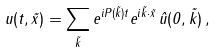<formula> <loc_0><loc_0><loc_500><loc_500>u ( t , \vec { x } ) = \sum _ { \vec { k } } e ^ { i P ( \vec { k } ) t } e ^ { i \vec { k } \cdot { \vec { x } } } \, \hat { u } ( 0 , \vec { k } ) \, ,</formula> 